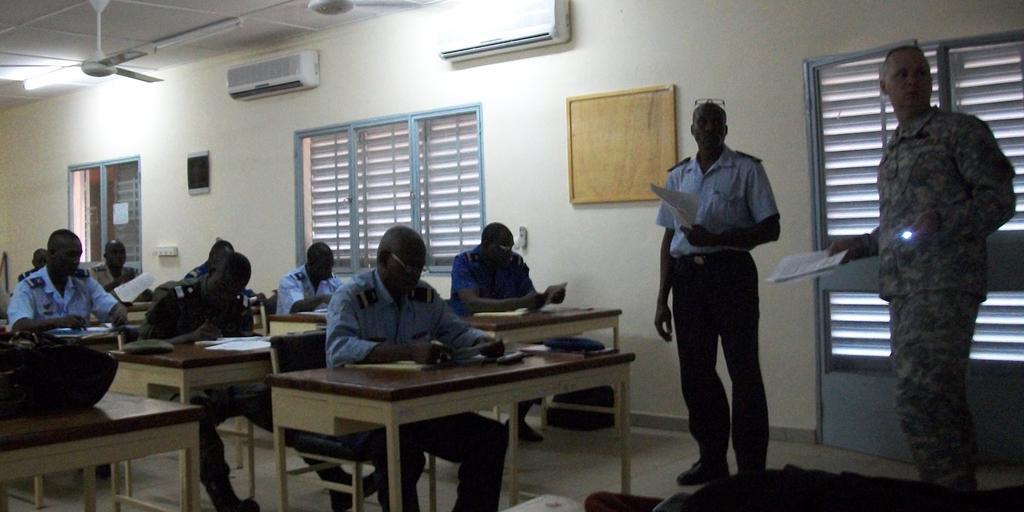How would you summarize this image in a sentence or two? It is an examination hall the students are sitting on the table and writing the exam,in front of that there are two examiners standing both of them are holding the papers in their hand in the background there are Windows, air conditioners to the wall. 